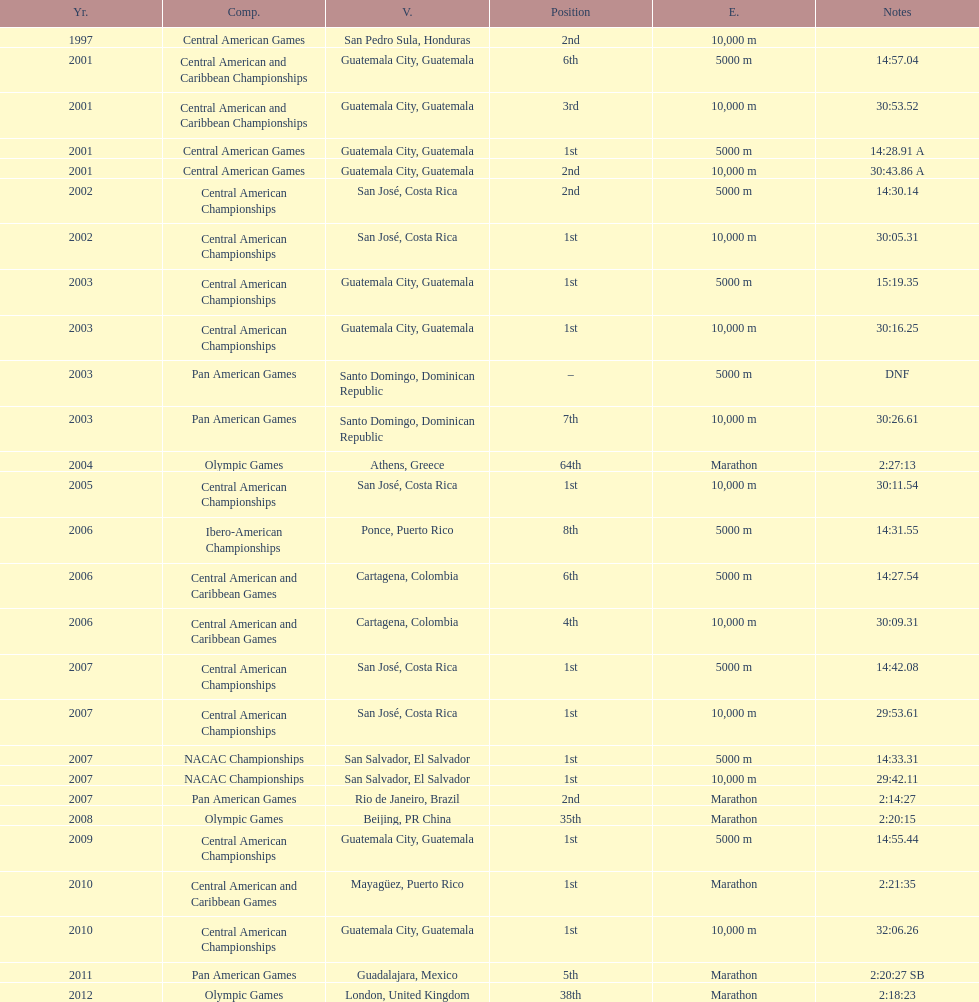In the latest competition, when was a standing of "2nd" secured? Pan American Games. 